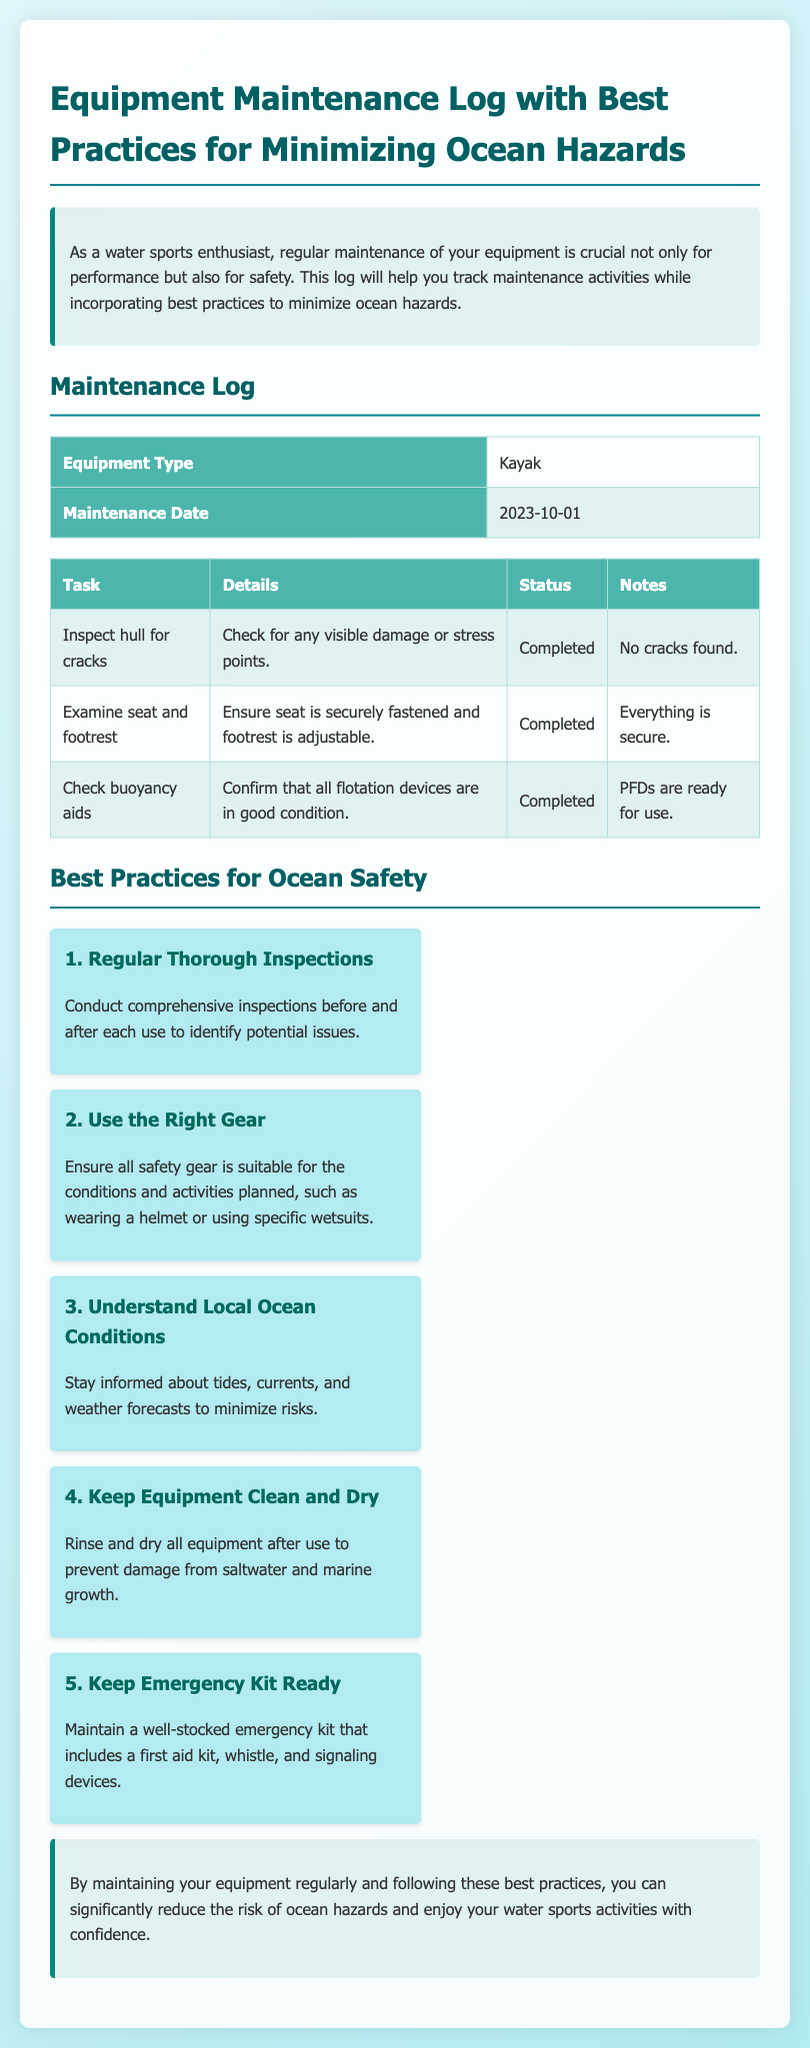What is the equipment type listed in the log? The equipment type is specified in the maintenance log section of the document.
Answer: Kayak What is the maintenance date recorded? The maintenance date is detailed in the maintenance log section and indicates when the equipment was last serviced.
Answer: 2023-10-01 How many tasks are listed in the maintenance log? The number of tasks can be counted in the maintenance log section of the document.
Answer: 3 What is the status of the task "Inspect hull for cracks"? The status of each task is found in the task details table, indicating whether tasks are completed or not.
Answer: Completed What is the first best practice mentioned for minimizing ocean hazards? The best practices section enumerates safety practices, with the first one clearly stated.
Answer: Regular Thorough Inspections What equipment should be maintained after use according to best practices? This information is found in the best practices section where it discusses keeping equipment in good condition.
Answer: Equipment What should be included in the emergency kit? The guidelines about the emergency kit can be found in the best practices section regarding safety equipment.
Answer: First aid kit How should equipment be treated after use? This detail is emphasized in the best practices section discussing maintenance procedures post-use.
Answer: Rinse and dry What color is the background gradient used in the document? The background color of the document can be described in terms of its visual design elements.
Answer: Light blue 